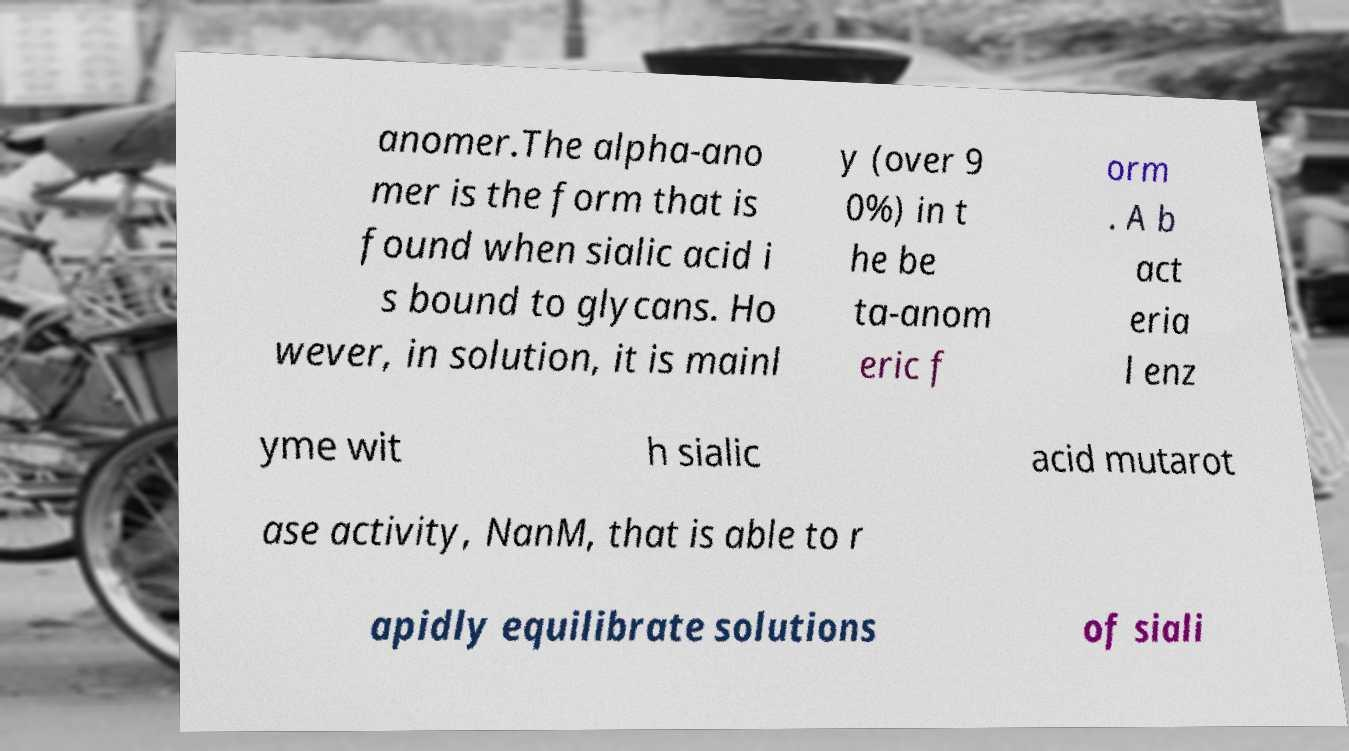Can you accurately transcribe the text from the provided image for me? anomer.The alpha-ano mer is the form that is found when sialic acid i s bound to glycans. Ho wever, in solution, it is mainl y (over 9 0%) in t he be ta-anom eric f orm . A b act eria l enz yme wit h sialic acid mutarot ase activity, NanM, that is able to r apidly equilibrate solutions of siali 